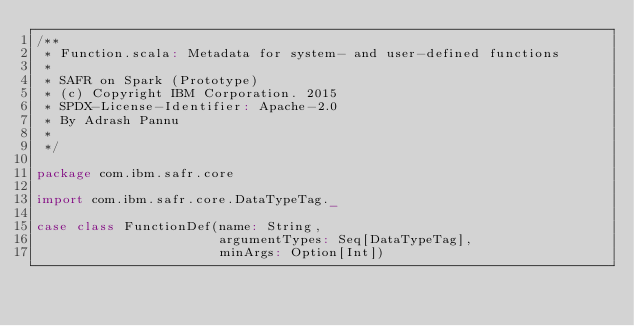Convert code to text. <code><loc_0><loc_0><loc_500><loc_500><_Scala_>/**
 * Function.scala: Metadata for system- and user-defined functions
 *
 * SAFR on Spark (Prototype)
 * (c) Copyright IBM Corporation. 2015
 * SPDX-License-Identifier: Apache-2.0
 * By Adrash Pannu
 *
 */

package com.ibm.safr.core

import com.ibm.safr.core.DataTypeTag._

case class FunctionDef(name: String,
                       argumentTypes: Seq[DataTypeTag],
                       minArgs: Option[Int])


</code> 